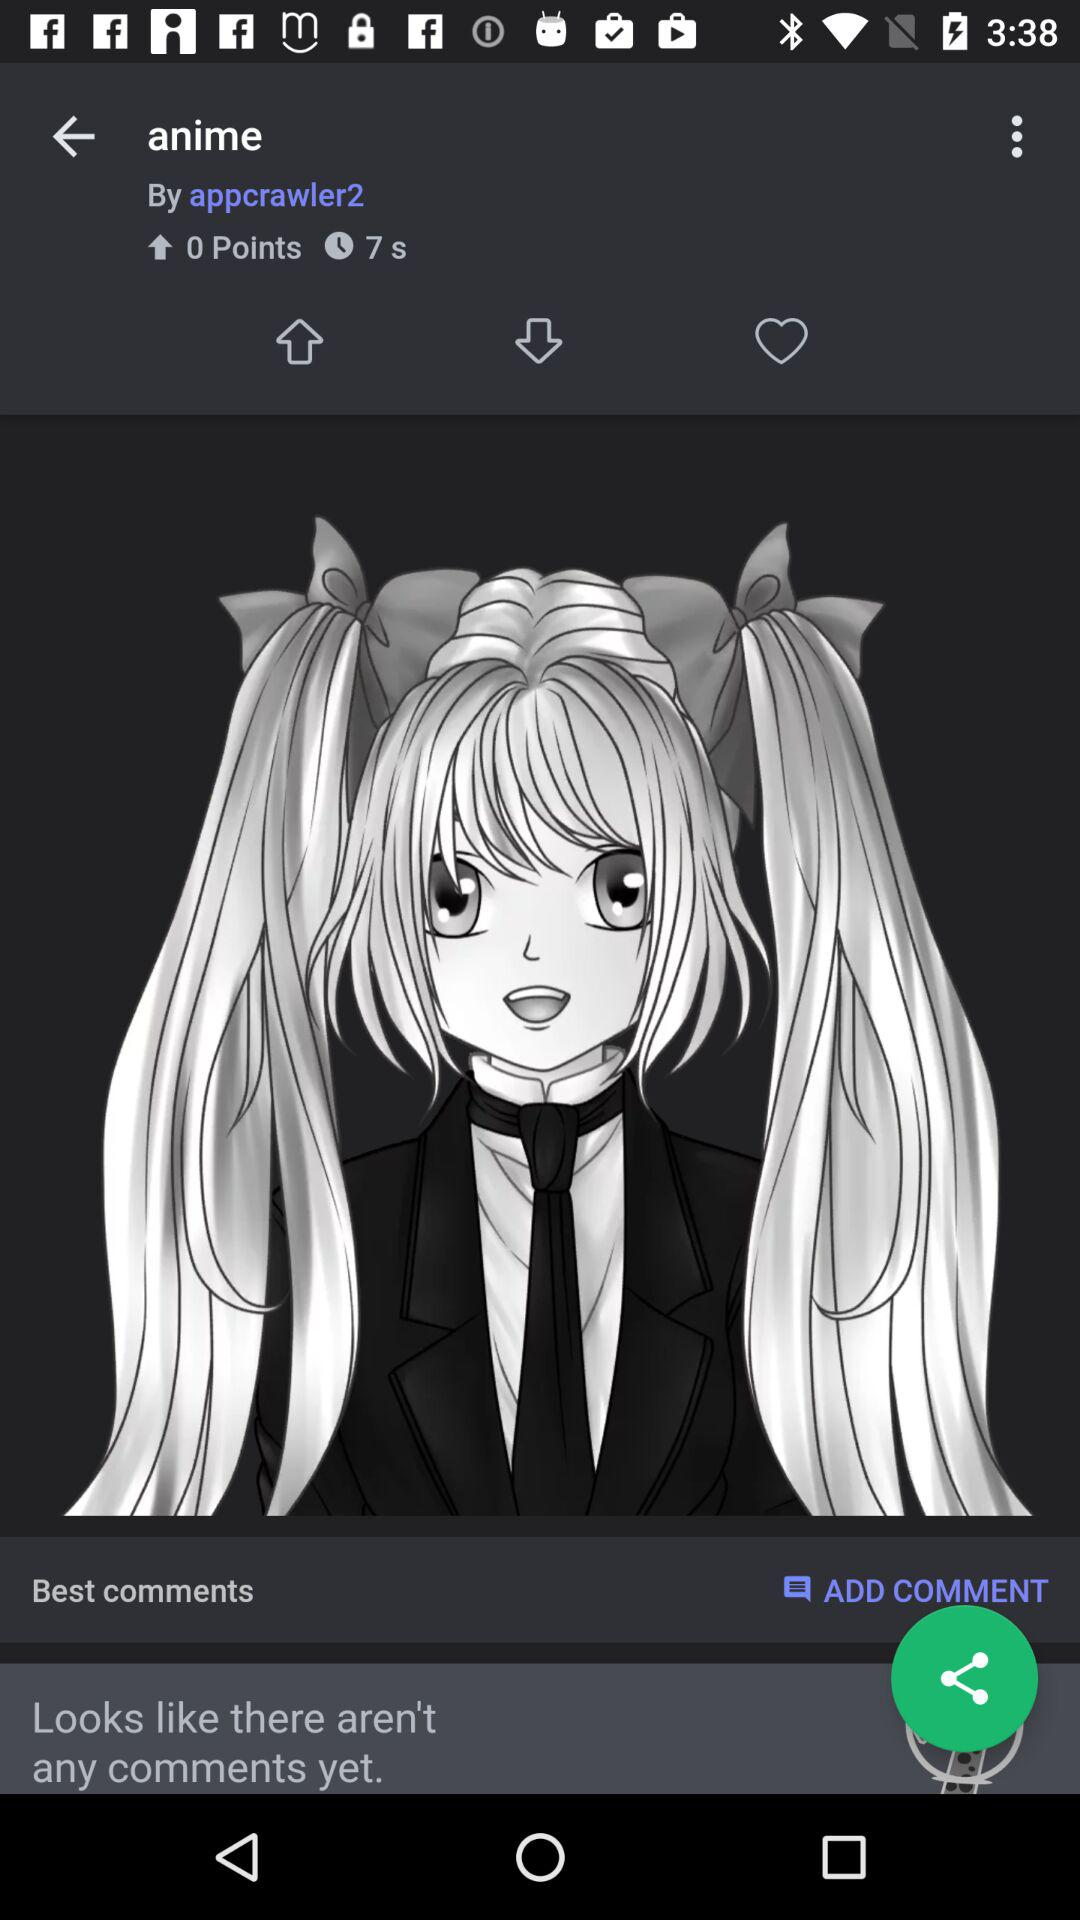How many more seconds are there than points?
Answer the question using a single word or phrase. 7 